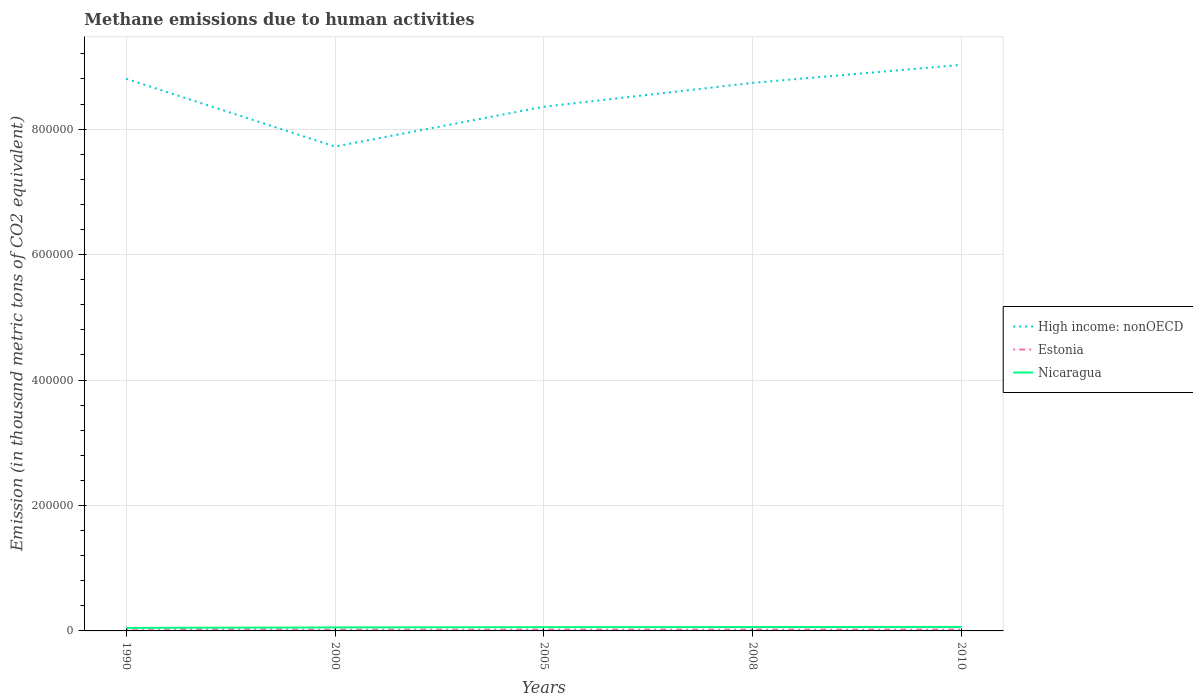Across all years, what is the maximum amount of methane emitted in Nicaragua?
Your answer should be very brief. 4811.3. In which year was the amount of methane emitted in Nicaragua maximum?
Provide a succinct answer. 1990. What is the total amount of methane emitted in High income: nonOECD in the graph?
Your answer should be compact. 1.08e+05. What is the difference between the highest and the second highest amount of methane emitted in Estonia?
Make the answer very short. 1272. How many years are there in the graph?
Your response must be concise. 5. Are the values on the major ticks of Y-axis written in scientific E-notation?
Provide a short and direct response. No. How are the legend labels stacked?
Provide a short and direct response. Vertical. What is the title of the graph?
Keep it short and to the point. Methane emissions due to human activities. Does "Yemen, Rep." appear as one of the legend labels in the graph?
Make the answer very short. No. What is the label or title of the X-axis?
Ensure brevity in your answer.  Years. What is the label or title of the Y-axis?
Ensure brevity in your answer.  Emission (in thousand metric tons of CO2 equivalent). What is the Emission (in thousand metric tons of CO2 equivalent) of High income: nonOECD in 1990?
Offer a very short reply. 8.80e+05. What is the Emission (in thousand metric tons of CO2 equivalent) of Estonia in 1990?
Provide a succinct answer. 3408.3. What is the Emission (in thousand metric tons of CO2 equivalent) in Nicaragua in 1990?
Provide a short and direct response. 4811.3. What is the Emission (in thousand metric tons of CO2 equivalent) of High income: nonOECD in 2000?
Ensure brevity in your answer.  7.72e+05. What is the Emission (in thousand metric tons of CO2 equivalent) in Estonia in 2000?
Offer a very short reply. 2136.3. What is the Emission (in thousand metric tons of CO2 equivalent) of Nicaragua in 2000?
Make the answer very short. 5565.7. What is the Emission (in thousand metric tons of CO2 equivalent) of High income: nonOECD in 2005?
Provide a short and direct response. 8.36e+05. What is the Emission (in thousand metric tons of CO2 equivalent) in Estonia in 2005?
Keep it short and to the point. 2212.3. What is the Emission (in thousand metric tons of CO2 equivalent) of Nicaragua in 2005?
Your response must be concise. 6045. What is the Emission (in thousand metric tons of CO2 equivalent) in High income: nonOECD in 2008?
Your answer should be compact. 8.74e+05. What is the Emission (in thousand metric tons of CO2 equivalent) in Estonia in 2008?
Offer a very short reply. 2252. What is the Emission (in thousand metric tons of CO2 equivalent) in Nicaragua in 2008?
Your answer should be compact. 6199.5. What is the Emission (in thousand metric tons of CO2 equivalent) of High income: nonOECD in 2010?
Offer a very short reply. 9.02e+05. What is the Emission (in thousand metric tons of CO2 equivalent) in Estonia in 2010?
Provide a short and direct response. 2329.3. What is the Emission (in thousand metric tons of CO2 equivalent) in Nicaragua in 2010?
Offer a very short reply. 6361.4. Across all years, what is the maximum Emission (in thousand metric tons of CO2 equivalent) of High income: nonOECD?
Your answer should be compact. 9.02e+05. Across all years, what is the maximum Emission (in thousand metric tons of CO2 equivalent) in Estonia?
Keep it short and to the point. 3408.3. Across all years, what is the maximum Emission (in thousand metric tons of CO2 equivalent) of Nicaragua?
Offer a terse response. 6361.4. Across all years, what is the minimum Emission (in thousand metric tons of CO2 equivalent) in High income: nonOECD?
Your answer should be very brief. 7.72e+05. Across all years, what is the minimum Emission (in thousand metric tons of CO2 equivalent) of Estonia?
Ensure brevity in your answer.  2136.3. Across all years, what is the minimum Emission (in thousand metric tons of CO2 equivalent) of Nicaragua?
Make the answer very short. 4811.3. What is the total Emission (in thousand metric tons of CO2 equivalent) in High income: nonOECD in the graph?
Offer a terse response. 4.26e+06. What is the total Emission (in thousand metric tons of CO2 equivalent) in Estonia in the graph?
Your response must be concise. 1.23e+04. What is the total Emission (in thousand metric tons of CO2 equivalent) of Nicaragua in the graph?
Make the answer very short. 2.90e+04. What is the difference between the Emission (in thousand metric tons of CO2 equivalent) in High income: nonOECD in 1990 and that in 2000?
Keep it short and to the point. 1.08e+05. What is the difference between the Emission (in thousand metric tons of CO2 equivalent) in Estonia in 1990 and that in 2000?
Offer a terse response. 1272. What is the difference between the Emission (in thousand metric tons of CO2 equivalent) of Nicaragua in 1990 and that in 2000?
Your response must be concise. -754.4. What is the difference between the Emission (in thousand metric tons of CO2 equivalent) in High income: nonOECD in 1990 and that in 2005?
Provide a short and direct response. 4.45e+04. What is the difference between the Emission (in thousand metric tons of CO2 equivalent) in Estonia in 1990 and that in 2005?
Provide a succinct answer. 1196. What is the difference between the Emission (in thousand metric tons of CO2 equivalent) in Nicaragua in 1990 and that in 2005?
Ensure brevity in your answer.  -1233.7. What is the difference between the Emission (in thousand metric tons of CO2 equivalent) in High income: nonOECD in 1990 and that in 2008?
Ensure brevity in your answer.  6496.2. What is the difference between the Emission (in thousand metric tons of CO2 equivalent) in Estonia in 1990 and that in 2008?
Your answer should be very brief. 1156.3. What is the difference between the Emission (in thousand metric tons of CO2 equivalent) in Nicaragua in 1990 and that in 2008?
Offer a terse response. -1388.2. What is the difference between the Emission (in thousand metric tons of CO2 equivalent) of High income: nonOECD in 1990 and that in 2010?
Make the answer very short. -2.23e+04. What is the difference between the Emission (in thousand metric tons of CO2 equivalent) of Estonia in 1990 and that in 2010?
Keep it short and to the point. 1079. What is the difference between the Emission (in thousand metric tons of CO2 equivalent) of Nicaragua in 1990 and that in 2010?
Offer a terse response. -1550.1. What is the difference between the Emission (in thousand metric tons of CO2 equivalent) in High income: nonOECD in 2000 and that in 2005?
Your answer should be compact. -6.35e+04. What is the difference between the Emission (in thousand metric tons of CO2 equivalent) of Estonia in 2000 and that in 2005?
Make the answer very short. -76. What is the difference between the Emission (in thousand metric tons of CO2 equivalent) in Nicaragua in 2000 and that in 2005?
Provide a short and direct response. -479.3. What is the difference between the Emission (in thousand metric tons of CO2 equivalent) of High income: nonOECD in 2000 and that in 2008?
Give a very brief answer. -1.02e+05. What is the difference between the Emission (in thousand metric tons of CO2 equivalent) in Estonia in 2000 and that in 2008?
Make the answer very short. -115.7. What is the difference between the Emission (in thousand metric tons of CO2 equivalent) in Nicaragua in 2000 and that in 2008?
Keep it short and to the point. -633.8. What is the difference between the Emission (in thousand metric tons of CO2 equivalent) of High income: nonOECD in 2000 and that in 2010?
Give a very brief answer. -1.30e+05. What is the difference between the Emission (in thousand metric tons of CO2 equivalent) of Estonia in 2000 and that in 2010?
Your response must be concise. -193. What is the difference between the Emission (in thousand metric tons of CO2 equivalent) in Nicaragua in 2000 and that in 2010?
Your answer should be compact. -795.7. What is the difference between the Emission (in thousand metric tons of CO2 equivalent) in High income: nonOECD in 2005 and that in 2008?
Ensure brevity in your answer.  -3.80e+04. What is the difference between the Emission (in thousand metric tons of CO2 equivalent) in Estonia in 2005 and that in 2008?
Offer a very short reply. -39.7. What is the difference between the Emission (in thousand metric tons of CO2 equivalent) of Nicaragua in 2005 and that in 2008?
Ensure brevity in your answer.  -154.5. What is the difference between the Emission (in thousand metric tons of CO2 equivalent) of High income: nonOECD in 2005 and that in 2010?
Your response must be concise. -6.68e+04. What is the difference between the Emission (in thousand metric tons of CO2 equivalent) of Estonia in 2005 and that in 2010?
Your response must be concise. -117. What is the difference between the Emission (in thousand metric tons of CO2 equivalent) of Nicaragua in 2005 and that in 2010?
Provide a short and direct response. -316.4. What is the difference between the Emission (in thousand metric tons of CO2 equivalent) in High income: nonOECD in 2008 and that in 2010?
Make the answer very short. -2.88e+04. What is the difference between the Emission (in thousand metric tons of CO2 equivalent) of Estonia in 2008 and that in 2010?
Offer a very short reply. -77.3. What is the difference between the Emission (in thousand metric tons of CO2 equivalent) of Nicaragua in 2008 and that in 2010?
Give a very brief answer. -161.9. What is the difference between the Emission (in thousand metric tons of CO2 equivalent) in High income: nonOECD in 1990 and the Emission (in thousand metric tons of CO2 equivalent) in Estonia in 2000?
Your answer should be very brief. 8.78e+05. What is the difference between the Emission (in thousand metric tons of CO2 equivalent) in High income: nonOECD in 1990 and the Emission (in thousand metric tons of CO2 equivalent) in Nicaragua in 2000?
Give a very brief answer. 8.75e+05. What is the difference between the Emission (in thousand metric tons of CO2 equivalent) in Estonia in 1990 and the Emission (in thousand metric tons of CO2 equivalent) in Nicaragua in 2000?
Offer a terse response. -2157.4. What is the difference between the Emission (in thousand metric tons of CO2 equivalent) in High income: nonOECD in 1990 and the Emission (in thousand metric tons of CO2 equivalent) in Estonia in 2005?
Keep it short and to the point. 8.78e+05. What is the difference between the Emission (in thousand metric tons of CO2 equivalent) of High income: nonOECD in 1990 and the Emission (in thousand metric tons of CO2 equivalent) of Nicaragua in 2005?
Keep it short and to the point. 8.74e+05. What is the difference between the Emission (in thousand metric tons of CO2 equivalent) in Estonia in 1990 and the Emission (in thousand metric tons of CO2 equivalent) in Nicaragua in 2005?
Make the answer very short. -2636.7. What is the difference between the Emission (in thousand metric tons of CO2 equivalent) of High income: nonOECD in 1990 and the Emission (in thousand metric tons of CO2 equivalent) of Estonia in 2008?
Your response must be concise. 8.78e+05. What is the difference between the Emission (in thousand metric tons of CO2 equivalent) in High income: nonOECD in 1990 and the Emission (in thousand metric tons of CO2 equivalent) in Nicaragua in 2008?
Offer a very short reply. 8.74e+05. What is the difference between the Emission (in thousand metric tons of CO2 equivalent) of Estonia in 1990 and the Emission (in thousand metric tons of CO2 equivalent) of Nicaragua in 2008?
Your answer should be compact. -2791.2. What is the difference between the Emission (in thousand metric tons of CO2 equivalent) in High income: nonOECD in 1990 and the Emission (in thousand metric tons of CO2 equivalent) in Estonia in 2010?
Give a very brief answer. 8.78e+05. What is the difference between the Emission (in thousand metric tons of CO2 equivalent) in High income: nonOECD in 1990 and the Emission (in thousand metric tons of CO2 equivalent) in Nicaragua in 2010?
Give a very brief answer. 8.74e+05. What is the difference between the Emission (in thousand metric tons of CO2 equivalent) in Estonia in 1990 and the Emission (in thousand metric tons of CO2 equivalent) in Nicaragua in 2010?
Your response must be concise. -2953.1. What is the difference between the Emission (in thousand metric tons of CO2 equivalent) of High income: nonOECD in 2000 and the Emission (in thousand metric tons of CO2 equivalent) of Estonia in 2005?
Your answer should be very brief. 7.70e+05. What is the difference between the Emission (in thousand metric tons of CO2 equivalent) in High income: nonOECD in 2000 and the Emission (in thousand metric tons of CO2 equivalent) in Nicaragua in 2005?
Provide a short and direct response. 7.66e+05. What is the difference between the Emission (in thousand metric tons of CO2 equivalent) in Estonia in 2000 and the Emission (in thousand metric tons of CO2 equivalent) in Nicaragua in 2005?
Provide a short and direct response. -3908.7. What is the difference between the Emission (in thousand metric tons of CO2 equivalent) of High income: nonOECD in 2000 and the Emission (in thousand metric tons of CO2 equivalent) of Estonia in 2008?
Give a very brief answer. 7.70e+05. What is the difference between the Emission (in thousand metric tons of CO2 equivalent) of High income: nonOECD in 2000 and the Emission (in thousand metric tons of CO2 equivalent) of Nicaragua in 2008?
Your response must be concise. 7.66e+05. What is the difference between the Emission (in thousand metric tons of CO2 equivalent) of Estonia in 2000 and the Emission (in thousand metric tons of CO2 equivalent) of Nicaragua in 2008?
Offer a very short reply. -4063.2. What is the difference between the Emission (in thousand metric tons of CO2 equivalent) of High income: nonOECD in 2000 and the Emission (in thousand metric tons of CO2 equivalent) of Estonia in 2010?
Give a very brief answer. 7.70e+05. What is the difference between the Emission (in thousand metric tons of CO2 equivalent) in High income: nonOECD in 2000 and the Emission (in thousand metric tons of CO2 equivalent) in Nicaragua in 2010?
Your answer should be compact. 7.66e+05. What is the difference between the Emission (in thousand metric tons of CO2 equivalent) in Estonia in 2000 and the Emission (in thousand metric tons of CO2 equivalent) in Nicaragua in 2010?
Give a very brief answer. -4225.1. What is the difference between the Emission (in thousand metric tons of CO2 equivalent) of High income: nonOECD in 2005 and the Emission (in thousand metric tons of CO2 equivalent) of Estonia in 2008?
Your response must be concise. 8.33e+05. What is the difference between the Emission (in thousand metric tons of CO2 equivalent) of High income: nonOECD in 2005 and the Emission (in thousand metric tons of CO2 equivalent) of Nicaragua in 2008?
Provide a succinct answer. 8.29e+05. What is the difference between the Emission (in thousand metric tons of CO2 equivalent) in Estonia in 2005 and the Emission (in thousand metric tons of CO2 equivalent) in Nicaragua in 2008?
Provide a succinct answer. -3987.2. What is the difference between the Emission (in thousand metric tons of CO2 equivalent) of High income: nonOECD in 2005 and the Emission (in thousand metric tons of CO2 equivalent) of Estonia in 2010?
Provide a succinct answer. 8.33e+05. What is the difference between the Emission (in thousand metric tons of CO2 equivalent) in High income: nonOECD in 2005 and the Emission (in thousand metric tons of CO2 equivalent) in Nicaragua in 2010?
Ensure brevity in your answer.  8.29e+05. What is the difference between the Emission (in thousand metric tons of CO2 equivalent) in Estonia in 2005 and the Emission (in thousand metric tons of CO2 equivalent) in Nicaragua in 2010?
Make the answer very short. -4149.1. What is the difference between the Emission (in thousand metric tons of CO2 equivalent) in High income: nonOECD in 2008 and the Emission (in thousand metric tons of CO2 equivalent) in Estonia in 2010?
Ensure brevity in your answer.  8.71e+05. What is the difference between the Emission (in thousand metric tons of CO2 equivalent) of High income: nonOECD in 2008 and the Emission (in thousand metric tons of CO2 equivalent) of Nicaragua in 2010?
Your response must be concise. 8.67e+05. What is the difference between the Emission (in thousand metric tons of CO2 equivalent) in Estonia in 2008 and the Emission (in thousand metric tons of CO2 equivalent) in Nicaragua in 2010?
Make the answer very short. -4109.4. What is the average Emission (in thousand metric tons of CO2 equivalent) of High income: nonOECD per year?
Your answer should be compact. 8.53e+05. What is the average Emission (in thousand metric tons of CO2 equivalent) of Estonia per year?
Your answer should be very brief. 2467.64. What is the average Emission (in thousand metric tons of CO2 equivalent) in Nicaragua per year?
Provide a succinct answer. 5796.58. In the year 1990, what is the difference between the Emission (in thousand metric tons of CO2 equivalent) of High income: nonOECD and Emission (in thousand metric tons of CO2 equivalent) of Estonia?
Provide a short and direct response. 8.77e+05. In the year 1990, what is the difference between the Emission (in thousand metric tons of CO2 equivalent) of High income: nonOECD and Emission (in thousand metric tons of CO2 equivalent) of Nicaragua?
Offer a terse response. 8.75e+05. In the year 1990, what is the difference between the Emission (in thousand metric tons of CO2 equivalent) in Estonia and Emission (in thousand metric tons of CO2 equivalent) in Nicaragua?
Your answer should be very brief. -1403. In the year 2000, what is the difference between the Emission (in thousand metric tons of CO2 equivalent) in High income: nonOECD and Emission (in thousand metric tons of CO2 equivalent) in Estonia?
Offer a terse response. 7.70e+05. In the year 2000, what is the difference between the Emission (in thousand metric tons of CO2 equivalent) of High income: nonOECD and Emission (in thousand metric tons of CO2 equivalent) of Nicaragua?
Your answer should be very brief. 7.67e+05. In the year 2000, what is the difference between the Emission (in thousand metric tons of CO2 equivalent) of Estonia and Emission (in thousand metric tons of CO2 equivalent) of Nicaragua?
Offer a very short reply. -3429.4. In the year 2005, what is the difference between the Emission (in thousand metric tons of CO2 equivalent) in High income: nonOECD and Emission (in thousand metric tons of CO2 equivalent) in Estonia?
Make the answer very short. 8.33e+05. In the year 2005, what is the difference between the Emission (in thousand metric tons of CO2 equivalent) in High income: nonOECD and Emission (in thousand metric tons of CO2 equivalent) in Nicaragua?
Your answer should be very brief. 8.30e+05. In the year 2005, what is the difference between the Emission (in thousand metric tons of CO2 equivalent) in Estonia and Emission (in thousand metric tons of CO2 equivalent) in Nicaragua?
Offer a terse response. -3832.7. In the year 2008, what is the difference between the Emission (in thousand metric tons of CO2 equivalent) of High income: nonOECD and Emission (in thousand metric tons of CO2 equivalent) of Estonia?
Keep it short and to the point. 8.71e+05. In the year 2008, what is the difference between the Emission (in thousand metric tons of CO2 equivalent) of High income: nonOECD and Emission (in thousand metric tons of CO2 equivalent) of Nicaragua?
Ensure brevity in your answer.  8.68e+05. In the year 2008, what is the difference between the Emission (in thousand metric tons of CO2 equivalent) of Estonia and Emission (in thousand metric tons of CO2 equivalent) of Nicaragua?
Offer a very short reply. -3947.5. In the year 2010, what is the difference between the Emission (in thousand metric tons of CO2 equivalent) in High income: nonOECD and Emission (in thousand metric tons of CO2 equivalent) in Estonia?
Your answer should be very brief. 9.00e+05. In the year 2010, what is the difference between the Emission (in thousand metric tons of CO2 equivalent) in High income: nonOECD and Emission (in thousand metric tons of CO2 equivalent) in Nicaragua?
Provide a succinct answer. 8.96e+05. In the year 2010, what is the difference between the Emission (in thousand metric tons of CO2 equivalent) in Estonia and Emission (in thousand metric tons of CO2 equivalent) in Nicaragua?
Your response must be concise. -4032.1. What is the ratio of the Emission (in thousand metric tons of CO2 equivalent) in High income: nonOECD in 1990 to that in 2000?
Your answer should be compact. 1.14. What is the ratio of the Emission (in thousand metric tons of CO2 equivalent) in Estonia in 1990 to that in 2000?
Offer a very short reply. 1.6. What is the ratio of the Emission (in thousand metric tons of CO2 equivalent) of Nicaragua in 1990 to that in 2000?
Offer a very short reply. 0.86. What is the ratio of the Emission (in thousand metric tons of CO2 equivalent) in High income: nonOECD in 1990 to that in 2005?
Your response must be concise. 1.05. What is the ratio of the Emission (in thousand metric tons of CO2 equivalent) in Estonia in 1990 to that in 2005?
Ensure brevity in your answer.  1.54. What is the ratio of the Emission (in thousand metric tons of CO2 equivalent) of Nicaragua in 1990 to that in 2005?
Your answer should be very brief. 0.8. What is the ratio of the Emission (in thousand metric tons of CO2 equivalent) in High income: nonOECD in 1990 to that in 2008?
Your answer should be compact. 1.01. What is the ratio of the Emission (in thousand metric tons of CO2 equivalent) in Estonia in 1990 to that in 2008?
Give a very brief answer. 1.51. What is the ratio of the Emission (in thousand metric tons of CO2 equivalent) of Nicaragua in 1990 to that in 2008?
Provide a short and direct response. 0.78. What is the ratio of the Emission (in thousand metric tons of CO2 equivalent) in High income: nonOECD in 1990 to that in 2010?
Provide a succinct answer. 0.98. What is the ratio of the Emission (in thousand metric tons of CO2 equivalent) of Estonia in 1990 to that in 2010?
Provide a short and direct response. 1.46. What is the ratio of the Emission (in thousand metric tons of CO2 equivalent) of Nicaragua in 1990 to that in 2010?
Ensure brevity in your answer.  0.76. What is the ratio of the Emission (in thousand metric tons of CO2 equivalent) of High income: nonOECD in 2000 to that in 2005?
Offer a very short reply. 0.92. What is the ratio of the Emission (in thousand metric tons of CO2 equivalent) of Estonia in 2000 to that in 2005?
Your response must be concise. 0.97. What is the ratio of the Emission (in thousand metric tons of CO2 equivalent) in Nicaragua in 2000 to that in 2005?
Provide a short and direct response. 0.92. What is the ratio of the Emission (in thousand metric tons of CO2 equivalent) of High income: nonOECD in 2000 to that in 2008?
Make the answer very short. 0.88. What is the ratio of the Emission (in thousand metric tons of CO2 equivalent) in Estonia in 2000 to that in 2008?
Keep it short and to the point. 0.95. What is the ratio of the Emission (in thousand metric tons of CO2 equivalent) in Nicaragua in 2000 to that in 2008?
Offer a terse response. 0.9. What is the ratio of the Emission (in thousand metric tons of CO2 equivalent) of High income: nonOECD in 2000 to that in 2010?
Ensure brevity in your answer.  0.86. What is the ratio of the Emission (in thousand metric tons of CO2 equivalent) in Estonia in 2000 to that in 2010?
Your response must be concise. 0.92. What is the ratio of the Emission (in thousand metric tons of CO2 equivalent) in Nicaragua in 2000 to that in 2010?
Your answer should be compact. 0.87. What is the ratio of the Emission (in thousand metric tons of CO2 equivalent) in High income: nonOECD in 2005 to that in 2008?
Make the answer very short. 0.96. What is the ratio of the Emission (in thousand metric tons of CO2 equivalent) in Estonia in 2005 to that in 2008?
Keep it short and to the point. 0.98. What is the ratio of the Emission (in thousand metric tons of CO2 equivalent) of Nicaragua in 2005 to that in 2008?
Give a very brief answer. 0.98. What is the ratio of the Emission (in thousand metric tons of CO2 equivalent) of High income: nonOECD in 2005 to that in 2010?
Offer a terse response. 0.93. What is the ratio of the Emission (in thousand metric tons of CO2 equivalent) of Estonia in 2005 to that in 2010?
Give a very brief answer. 0.95. What is the ratio of the Emission (in thousand metric tons of CO2 equivalent) of Nicaragua in 2005 to that in 2010?
Offer a terse response. 0.95. What is the ratio of the Emission (in thousand metric tons of CO2 equivalent) of High income: nonOECD in 2008 to that in 2010?
Your answer should be very brief. 0.97. What is the ratio of the Emission (in thousand metric tons of CO2 equivalent) in Estonia in 2008 to that in 2010?
Provide a short and direct response. 0.97. What is the ratio of the Emission (in thousand metric tons of CO2 equivalent) in Nicaragua in 2008 to that in 2010?
Your answer should be very brief. 0.97. What is the difference between the highest and the second highest Emission (in thousand metric tons of CO2 equivalent) of High income: nonOECD?
Offer a terse response. 2.23e+04. What is the difference between the highest and the second highest Emission (in thousand metric tons of CO2 equivalent) in Estonia?
Your response must be concise. 1079. What is the difference between the highest and the second highest Emission (in thousand metric tons of CO2 equivalent) in Nicaragua?
Offer a very short reply. 161.9. What is the difference between the highest and the lowest Emission (in thousand metric tons of CO2 equivalent) in High income: nonOECD?
Give a very brief answer. 1.30e+05. What is the difference between the highest and the lowest Emission (in thousand metric tons of CO2 equivalent) in Estonia?
Keep it short and to the point. 1272. What is the difference between the highest and the lowest Emission (in thousand metric tons of CO2 equivalent) in Nicaragua?
Make the answer very short. 1550.1. 